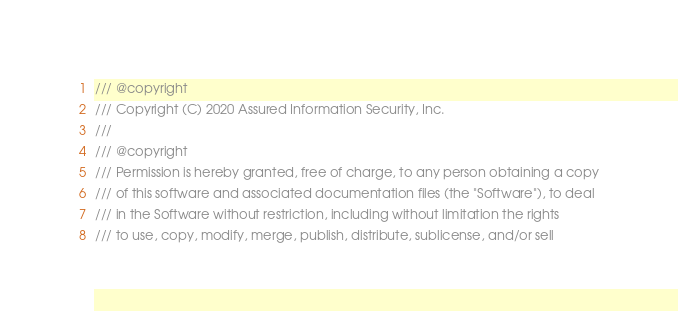Convert code to text. <code><loc_0><loc_0><loc_500><loc_500><_C++_>/// @copyright
/// Copyright (C) 2020 Assured Information Security, Inc.
///
/// @copyright
/// Permission is hereby granted, free of charge, to any person obtaining a copy
/// of this software and associated documentation files (the "Software"), to deal
/// in the Software without restriction, including without limitation the rights
/// to use, copy, modify, merge, publish, distribute, sublicense, and/or sell</code> 